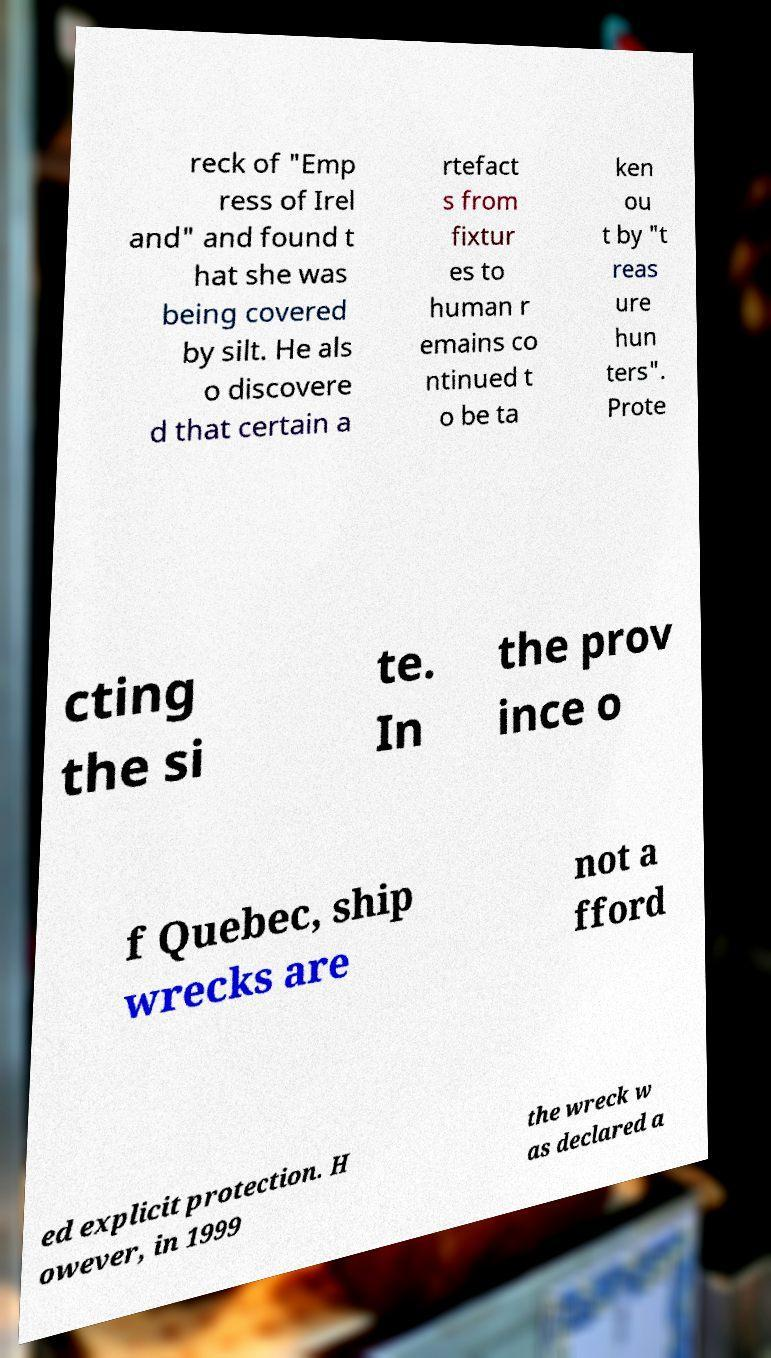Could you extract and type out the text from this image? reck of "Emp ress of Irel and" and found t hat she was being covered by silt. He als o discovere d that certain a rtefact s from fixtur es to human r emains co ntinued t o be ta ken ou t by "t reas ure hun ters". Prote cting the si te. In the prov ince o f Quebec, ship wrecks are not a fford ed explicit protection. H owever, in 1999 the wreck w as declared a 